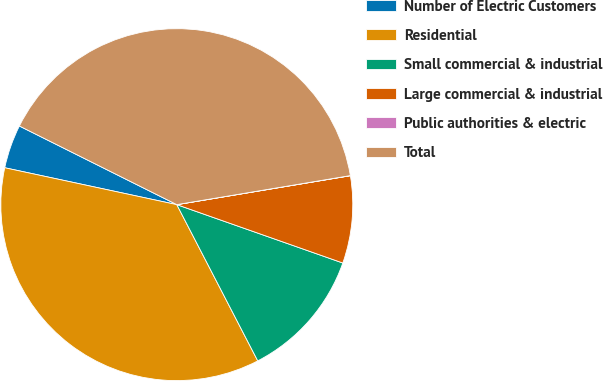Convert chart to OTSL. <chart><loc_0><loc_0><loc_500><loc_500><pie_chart><fcel>Number of Electric Customers<fcel>Residential<fcel>Small commercial & industrial<fcel>Large commercial & industrial<fcel>Public authorities & electric<fcel>Total<nl><fcel>4.01%<fcel>35.97%<fcel>12.01%<fcel>8.01%<fcel>0.01%<fcel>39.99%<nl></chart> 